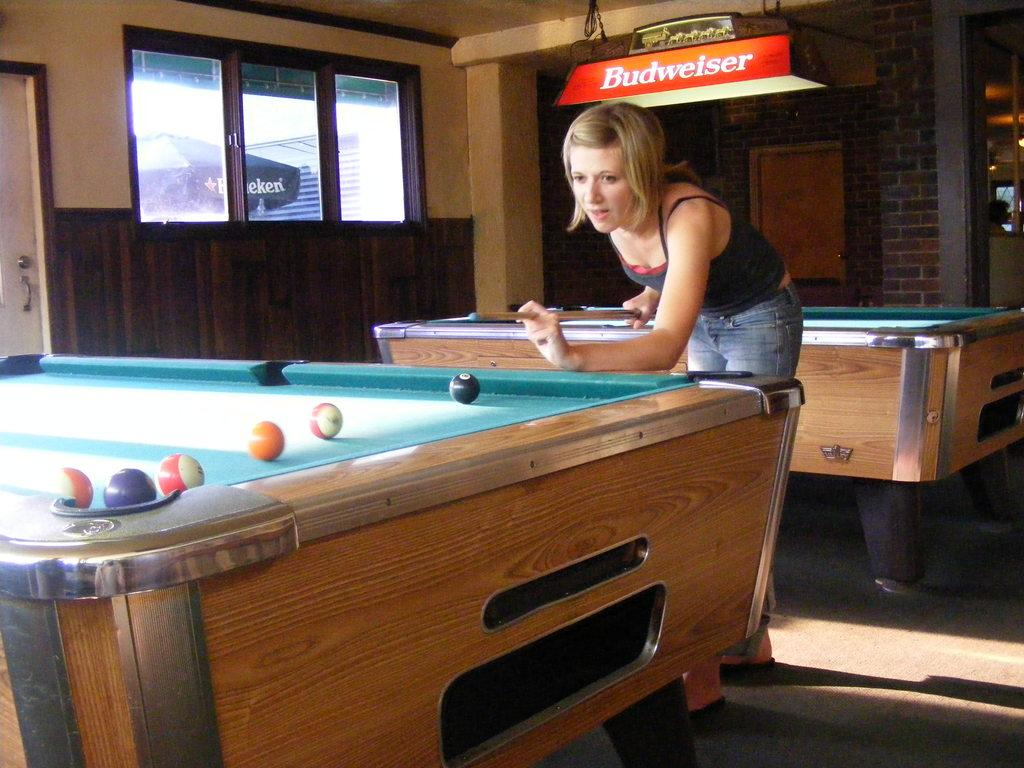Who is the main subject in the image? There is a woman in the image. What is the woman holding in her hand? The woman is holding a stick, likely a pool cue, in her hand. What activity is the woman engaged in? The woman is playing 8 ball pool. What is the level of pollution in the image? There is no information about pollution in the image, as it focuses on the woman playing 8 ball pool. How much zinc is present in the pool table in the image? There is no information about zinc in the image, as it focuses on the woman playing 8 ball pool. 